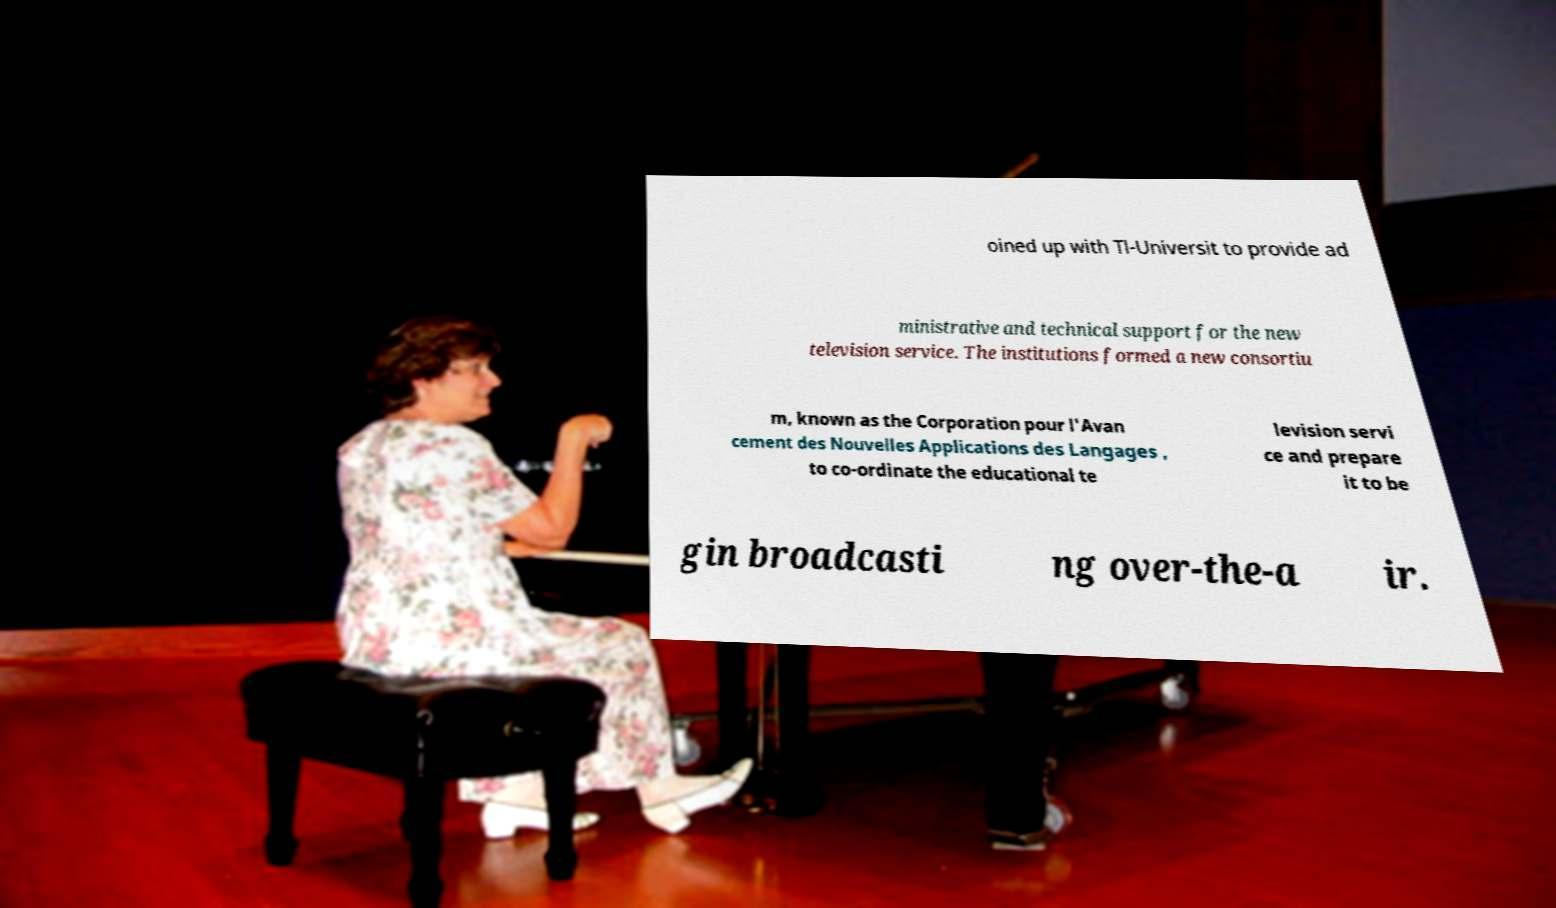Can you read and provide the text displayed in the image?This photo seems to have some interesting text. Can you extract and type it out for me? oined up with Tl-Universit to provide ad ministrative and technical support for the new television service. The institutions formed a new consortiu m, known as the Corporation pour l'Avan cement des Nouvelles Applications des Langages , to co-ordinate the educational te levision servi ce and prepare it to be gin broadcasti ng over-the-a ir. 